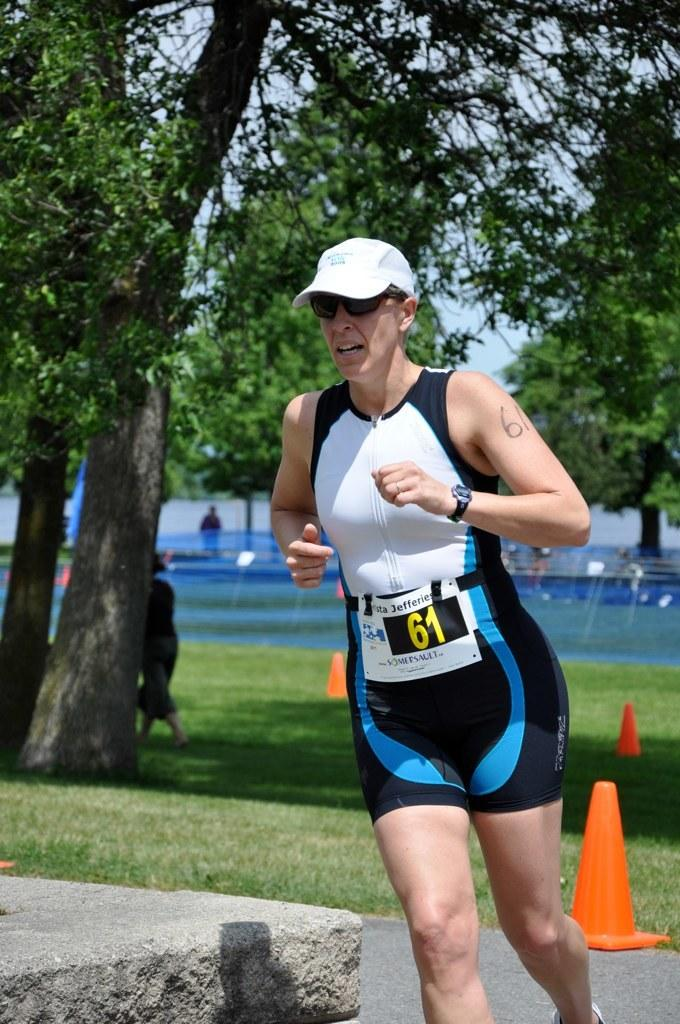Who is present in the image? There is a woman in the image. What is the woman wearing on her head? The woman is wearing a cap. What is the woman wearing to protect her eyes? The woman is wearing goggles. What activity is the woman engaged in? The woman is running. What type of terrain can be seen in the image? There is grass in the image. What object is present in the image that is typically used to direct traffic? There is a traffic cone in the image. What type of vegetation is visible in the image? There are trees in the image. What is visible at the top of the image? The sky is visible at the top of the image. What type of scissors can be seen cutting the grass in the image? There are no scissors present in the image; the woman is running, and the grass is not being cut. Can you describe the flock of animals visible in the image? There are no animals or flocks present in the image; it features a woman running, grass, a traffic cone, trees, and the sky. 